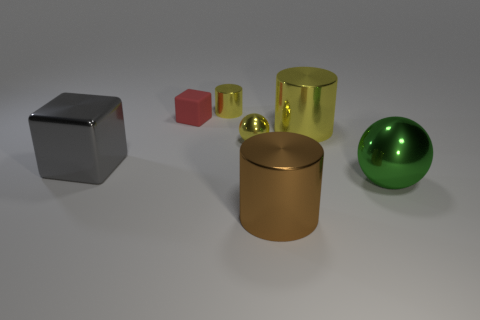Add 2 large red metal things. How many objects exist? 9 Subtract all spheres. How many objects are left? 5 Add 1 shiny objects. How many shiny objects exist? 7 Subtract 0 yellow cubes. How many objects are left? 7 Subtract all big metal spheres. Subtract all gray shiny blocks. How many objects are left? 5 Add 3 red rubber blocks. How many red rubber blocks are left? 4 